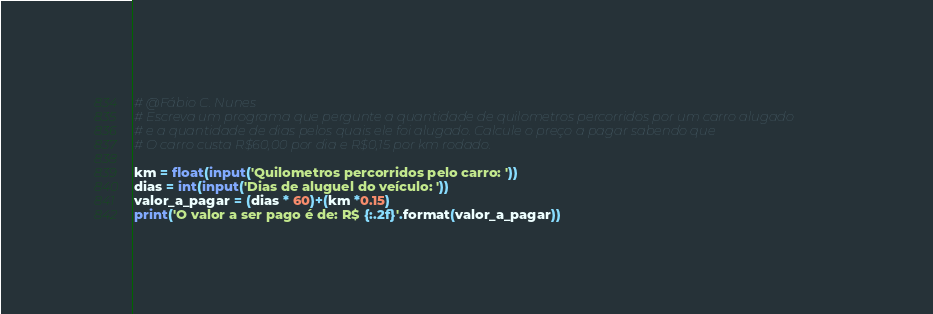<code> <loc_0><loc_0><loc_500><loc_500><_Python_># @Fábio C. Nunes
# Escreva um programa que pergunte a quantidade de quilometros percorridos por um carro alugado
# e a quantidade de dias pelos quais ele foi alugado. Calcule o preço a pagar sabendo que
# O carro custa R$60,00 por dia e R$0,15 por km rodado.

km = float(input('Quilometros percorridos pelo carro: '))
dias = int(input('Dias de aluguel do veículo: '))
valor_a_pagar = (dias * 60)+(km *0.15)
print('O valor a ser pago é de: R$ {:.2f}'.format(valor_a_pagar))

</code> 